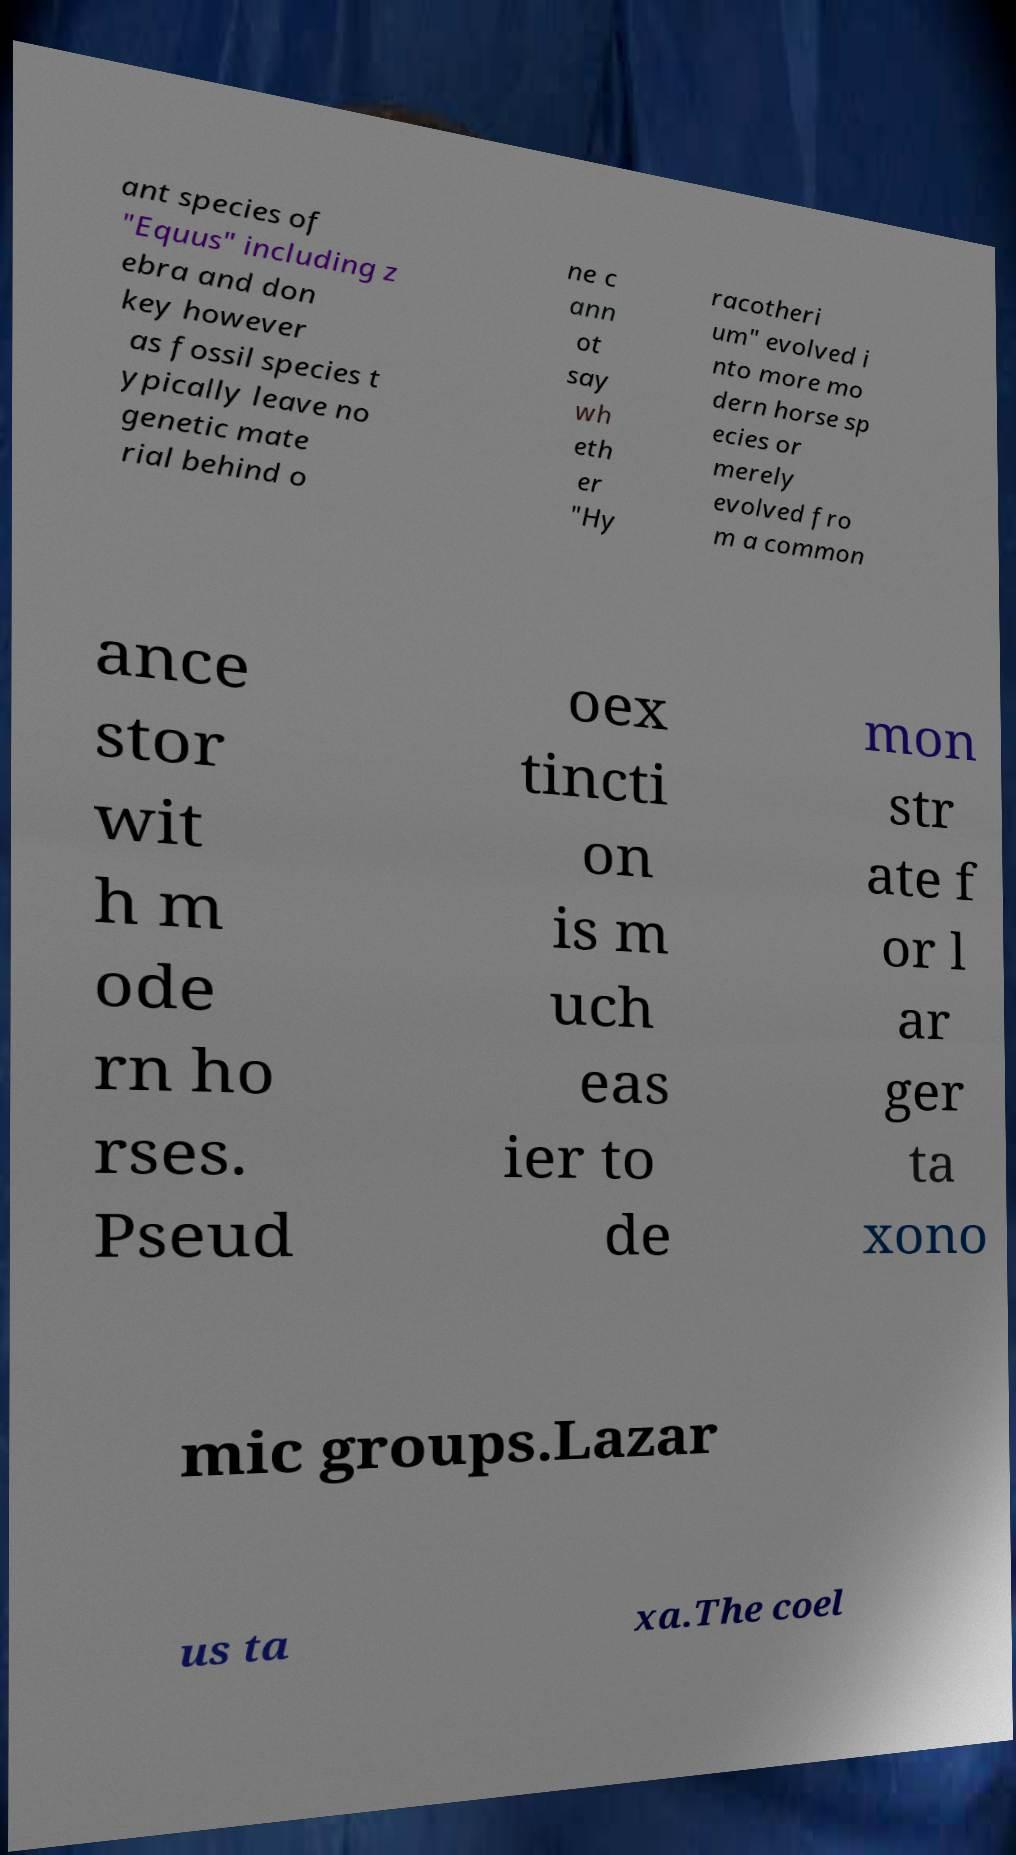There's text embedded in this image that I need extracted. Can you transcribe it verbatim? ant species of "Equus" including z ebra and don key however as fossil species t ypically leave no genetic mate rial behind o ne c ann ot say wh eth er "Hy racotheri um" evolved i nto more mo dern horse sp ecies or merely evolved fro m a common ance stor wit h m ode rn ho rses. Pseud oex tincti on is m uch eas ier to de mon str ate f or l ar ger ta xono mic groups.Lazar us ta xa.The coel 